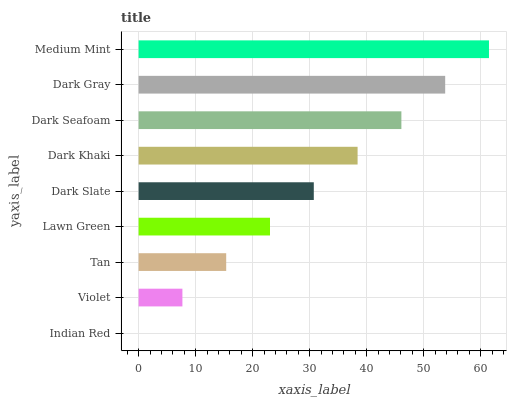Is Indian Red the minimum?
Answer yes or no. Yes. Is Medium Mint the maximum?
Answer yes or no. Yes. Is Violet the minimum?
Answer yes or no. No. Is Violet the maximum?
Answer yes or no. No. Is Violet greater than Indian Red?
Answer yes or no. Yes. Is Indian Red less than Violet?
Answer yes or no. Yes. Is Indian Red greater than Violet?
Answer yes or no. No. Is Violet less than Indian Red?
Answer yes or no. No. Is Dark Slate the high median?
Answer yes or no. Yes. Is Dark Slate the low median?
Answer yes or no. Yes. Is Dark Gray the high median?
Answer yes or no. No. Is Dark Gray the low median?
Answer yes or no. No. 